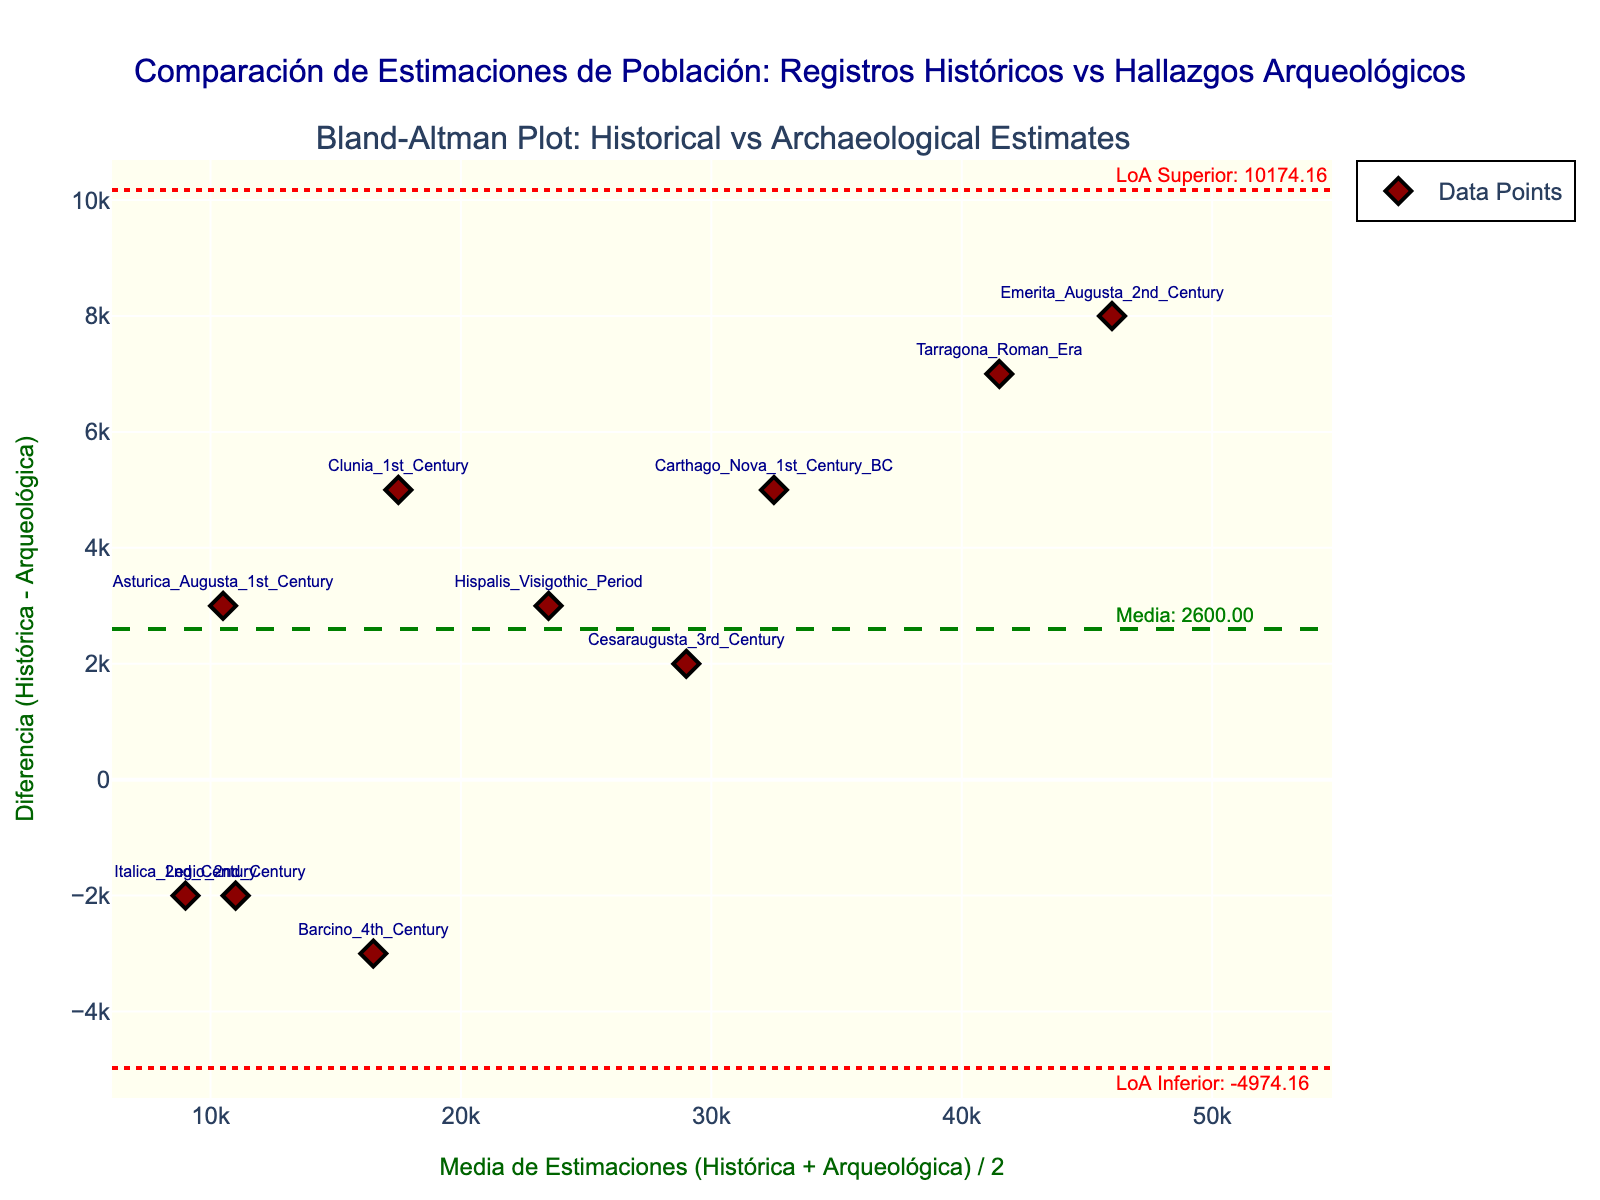¿Qué ciudad antigua tiene la diferencia más grande entre las estimaciones históricas y arqueológicas? Observamos la dispersión de puntos en el gráfico y vemos que el punto con la diferencia máxima se encuentra en Carthago Nova, con una diferencia de 5000 personas.
Answer: Carthago Nova ¿Cuál es el título del gráfico? El título del gráfico está ubicado en la parte superior dentro del gráfico, escrito en un color oscuro que contrasta con el fondo.
Answer: Comparación de Estimaciones de Población: Registros Históricos vs Hallazgos Arqueológicos ¿Cuál es la media de las diferencias entre las estimaciones históricas y arqueológicas? Localizamos la línea media verde punteada en el gráfico y leemos la anotación en el extremo derecho que indica "Media: 5000".
Answer: 5000 ¿Cuáles son los límites de acuerdo (Limits of Agreement, LoA) para este gráfico? Observamos las dos líneas rojas punteadas y leemos las anotaciones 'LoA Inferior' y 'LoA Superior' en el extremo derecho. Los valores son -2098.11 y 12098.11, respectivamente.
Answer: -2098.11, 12098.11 ¿Cuál de las ciudades antiguas tiene una diferencia negativa en las estimaciones y qué significa eso? Buscamos los puntos que están por debajo del eje x en el gráfico. El punto de Barcino tiene una diferencia negativa (-3000), lo que significa que la población arqueológica es mayor que la histórica.
Answer: Barcino ¿Cuántas ciudades antiguas tienen estimaciones históricas mayores que las arqueológicas? Contamos los puntos por encima del eje x en el gráfico, que representan diferencias positivas. Hay 8 puntos encima del eje, indicando 8 ciudades.
Answer: 8 ciudades ¿Qué ciudad tiene la media más alta entre las estimaciones históricas y arqueológicas? Localizamos el punto más a la derecha en el eje x, que pertenece a Emerita Augusta 2nd Century con una media de 46000 personas.
Answer: Emerita Augusta 2nd Century ¿Cuál es la media de estimaciones para la ciudad de Hispalis en el período visigótico? La coordenada x del punto 'Hispalis' nos da la media, que se encuentra en 23500 personas.
Answer: 23500 ¿Cómo se comparan las estimaciones para Asturica Augusta en el siglo I con las de Italica en el siglo II? Encontramos los puntos correspondientes y comparamos sus diferencias. Asturica Augusta tiene una diferencia de 3000 y Italica una diferencia de -2000 en las estimaciones. Así que Asturica Augusta tiene mayores diferencias.
Answer: Asturica Augusta tiene mayores diferencias ¿Cuáles son las ciudades antiguas con una diferencia de estimaciones menor de 5000? Observamos los puntos con diferencias (eje y) menores de 5000 en valor absoluto. Las ciudades son Cesaraugusta 3rd Century, Legio 2nd Century, y Italica 2nd Century.
Answer: Cesaraugusta 3rd Century, Legio 2nd Century, Italica 2nd Century 